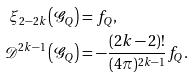<formula> <loc_0><loc_0><loc_500><loc_500>\xi _ { 2 - 2 k } \left ( \mathcal { G } _ { Q } \right ) & = f _ { Q } , \\ \mathcal { D } ^ { 2 k - 1 } \left ( \mathcal { G } _ { Q } \right ) & = - \frac { ( 2 k - 2 ) ! } { ( 4 \pi ) ^ { 2 k - 1 } } f _ { Q } .</formula> 